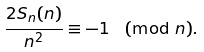<formula> <loc_0><loc_0><loc_500><loc_500>\frac { 2 S _ { n } ( n ) } { n ^ { 2 } } \equiv - 1 \pmod { n } .</formula> 